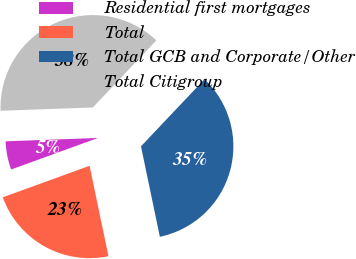<chart> <loc_0><loc_0><loc_500><loc_500><pie_chart><fcel>Residential first mortgages<fcel>Total<fcel>Total GCB and Corporate/Other<fcel>Total Citigroup<nl><fcel>4.97%<fcel>22.73%<fcel>34.66%<fcel>37.63%<nl></chart> 